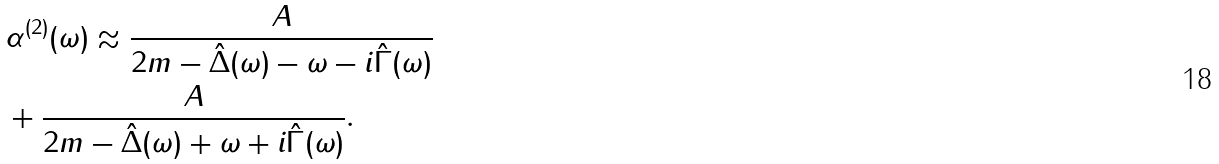Convert formula to latex. <formula><loc_0><loc_0><loc_500><loc_500>& \alpha ^ { ( 2 ) } ( \omega ) \approx \frac { A } { 2 m - { \hat { \Delta } } ( \omega ) - \omega - i { \hat { \Gamma } } ( \omega ) } \\ & + \frac { A } { 2 m - { \hat { \Delta } } ( \omega ) + \omega + i { \hat { \Gamma } } ( \omega ) } .</formula> 